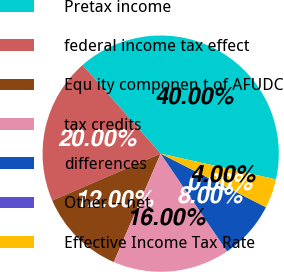Convert chart. <chart><loc_0><loc_0><loc_500><loc_500><pie_chart><fcel>Pretax income<fcel>federal income tax effect<fcel>Equ ity componen t of AFUDC<fcel>tax credits<fcel>differences<fcel>Other -- net<fcel>Effective Income Tax Rate<nl><fcel>40.0%<fcel>20.0%<fcel>12.0%<fcel>16.0%<fcel>8.0%<fcel>0.0%<fcel>4.0%<nl></chart> 